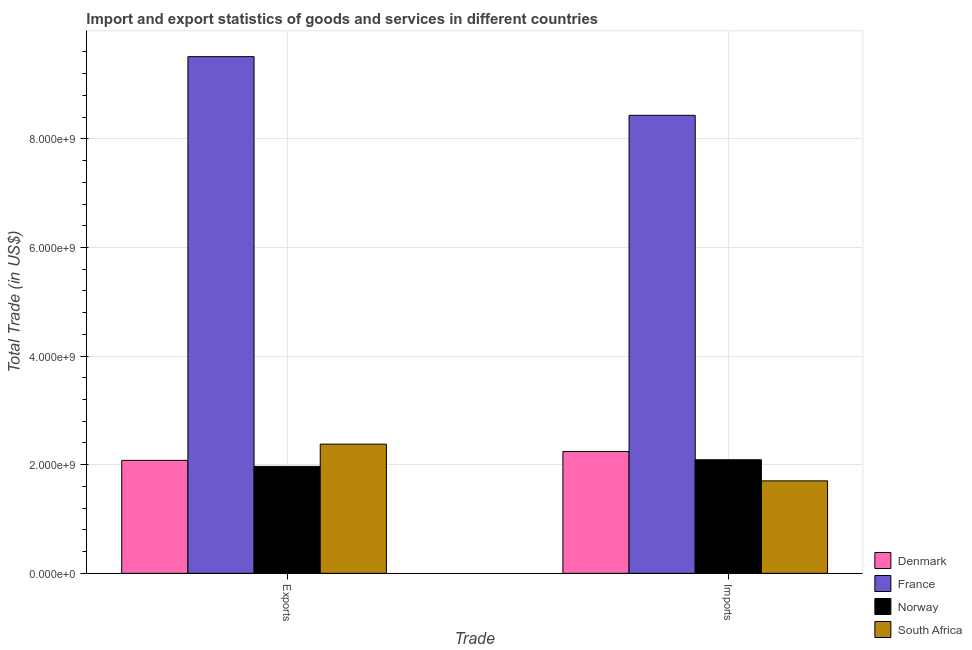How many groups of bars are there?
Your answer should be very brief. 2. Are the number of bars per tick equal to the number of legend labels?
Offer a terse response. Yes. How many bars are there on the 2nd tick from the left?
Your answer should be very brief. 4. What is the label of the 1st group of bars from the left?
Give a very brief answer. Exports. What is the imports of goods and services in Norway?
Offer a terse response. 2.09e+09. Across all countries, what is the maximum export of goods and services?
Your answer should be compact. 9.51e+09. Across all countries, what is the minimum imports of goods and services?
Your answer should be compact. 1.70e+09. In which country was the export of goods and services maximum?
Your response must be concise. France. In which country was the export of goods and services minimum?
Ensure brevity in your answer.  Norway. What is the total export of goods and services in the graph?
Provide a succinct answer. 1.59e+1. What is the difference between the export of goods and services in Norway and that in South Africa?
Your answer should be compact. -4.10e+08. What is the difference between the export of goods and services in Norway and the imports of goods and services in South Africa?
Provide a succinct answer. 2.66e+08. What is the average imports of goods and services per country?
Your response must be concise. 3.62e+09. What is the difference between the export of goods and services and imports of goods and services in South Africa?
Ensure brevity in your answer.  6.77e+08. What is the ratio of the imports of goods and services in Denmark to that in South Africa?
Your answer should be compact. 1.32. Is the imports of goods and services in France less than that in Norway?
Offer a terse response. No. What does the 1st bar from the left in Imports represents?
Ensure brevity in your answer.  Denmark. What does the 2nd bar from the right in Exports represents?
Your answer should be very brief. Norway. How many bars are there?
Provide a short and direct response. 8. Are all the bars in the graph horizontal?
Provide a short and direct response. No. How many countries are there in the graph?
Provide a succinct answer. 4. How are the legend labels stacked?
Offer a terse response. Vertical. What is the title of the graph?
Your answer should be very brief. Import and export statistics of goods and services in different countries. What is the label or title of the X-axis?
Keep it short and to the point. Trade. What is the label or title of the Y-axis?
Your answer should be very brief. Total Trade (in US$). What is the Total Trade (in US$) in Denmark in Exports?
Give a very brief answer. 2.08e+09. What is the Total Trade (in US$) of France in Exports?
Your answer should be compact. 9.51e+09. What is the Total Trade (in US$) in Norway in Exports?
Your response must be concise. 1.97e+09. What is the Total Trade (in US$) in South Africa in Exports?
Your response must be concise. 2.38e+09. What is the Total Trade (in US$) of Denmark in Imports?
Keep it short and to the point. 2.24e+09. What is the Total Trade (in US$) of France in Imports?
Keep it short and to the point. 8.43e+09. What is the Total Trade (in US$) of Norway in Imports?
Provide a short and direct response. 2.09e+09. What is the Total Trade (in US$) of South Africa in Imports?
Your answer should be very brief. 1.70e+09. Across all Trade, what is the maximum Total Trade (in US$) in Denmark?
Keep it short and to the point. 2.24e+09. Across all Trade, what is the maximum Total Trade (in US$) in France?
Provide a succinct answer. 9.51e+09. Across all Trade, what is the maximum Total Trade (in US$) in Norway?
Offer a terse response. 2.09e+09. Across all Trade, what is the maximum Total Trade (in US$) of South Africa?
Offer a terse response. 2.38e+09. Across all Trade, what is the minimum Total Trade (in US$) of Denmark?
Your answer should be very brief. 2.08e+09. Across all Trade, what is the minimum Total Trade (in US$) in France?
Your answer should be very brief. 8.43e+09. Across all Trade, what is the minimum Total Trade (in US$) of Norway?
Give a very brief answer. 1.97e+09. Across all Trade, what is the minimum Total Trade (in US$) in South Africa?
Provide a short and direct response. 1.70e+09. What is the total Total Trade (in US$) of Denmark in the graph?
Your answer should be very brief. 4.32e+09. What is the total Total Trade (in US$) of France in the graph?
Provide a short and direct response. 1.79e+1. What is the total Total Trade (in US$) of Norway in the graph?
Give a very brief answer. 4.06e+09. What is the total Total Trade (in US$) in South Africa in the graph?
Your response must be concise. 4.08e+09. What is the difference between the Total Trade (in US$) of Denmark in Exports and that in Imports?
Offer a terse response. -1.63e+08. What is the difference between the Total Trade (in US$) in France in Exports and that in Imports?
Provide a succinct answer. 1.08e+09. What is the difference between the Total Trade (in US$) of Norway in Exports and that in Imports?
Offer a very short reply. -1.23e+08. What is the difference between the Total Trade (in US$) in South Africa in Exports and that in Imports?
Offer a very short reply. 6.77e+08. What is the difference between the Total Trade (in US$) of Denmark in Exports and the Total Trade (in US$) of France in Imports?
Provide a succinct answer. -6.35e+09. What is the difference between the Total Trade (in US$) of Denmark in Exports and the Total Trade (in US$) of Norway in Imports?
Your answer should be very brief. -1.15e+07. What is the difference between the Total Trade (in US$) of Denmark in Exports and the Total Trade (in US$) of South Africa in Imports?
Give a very brief answer. 3.78e+08. What is the difference between the Total Trade (in US$) of France in Exports and the Total Trade (in US$) of Norway in Imports?
Ensure brevity in your answer.  7.42e+09. What is the difference between the Total Trade (in US$) in France in Exports and the Total Trade (in US$) in South Africa in Imports?
Ensure brevity in your answer.  7.81e+09. What is the difference between the Total Trade (in US$) of Norway in Exports and the Total Trade (in US$) of South Africa in Imports?
Offer a terse response. 2.66e+08. What is the average Total Trade (in US$) in Denmark per Trade?
Provide a short and direct response. 2.16e+09. What is the average Total Trade (in US$) of France per Trade?
Provide a succinct answer. 8.97e+09. What is the average Total Trade (in US$) in Norway per Trade?
Your answer should be very brief. 2.03e+09. What is the average Total Trade (in US$) in South Africa per Trade?
Your answer should be very brief. 2.04e+09. What is the difference between the Total Trade (in US$) of Denmark and Total Trade (in US$) of France in Exports?
Your answer should be very brief. -7.43e+09. What is the difference between the Total Trade (in US$) in Denmark and Total Trade (in US$) in Norway in Exports?
Provide a short and direct response. 1.11e+08. What is the difference between the Total Trade (in US$) of Denmark and Total Trade (in US$) of South Africa in Exports?
Your answer should be compact. -2.99e+08. What is the difference between the Total Trade (in US$) in France and Total Trade (in US$) in Norway in Exports?
Your response must be concise. 7.54e+09. What is the difference between the Total Trade (in US$) of France and Total Trade (in US$) of South Africa in Exports?
Your answer should be very brief. 7.13e+09. What is the difference between the Total Trade (in US$) in Norway and Total Trade (in US$) in South Africa in Exports?
Give a very brief answer. -4.10e+08. What is the difference between the Total Trade (in US$) in Denmark and Total Trade (in US$) in France in Imports?
Your response must be concise. -6.19e+09. What is the difference between the Total Trade (in US$) of Denmark and Total Trade (in US$) of Norway in Imports?
Ensure brevity in your answer.  1.51e+08. What is the difference between the Total Trade (in US$) in Denmark and Total Trade (in US$) in South Africa in Imports?
Your answer should be very brief. 5.40e+08. What is the difference between the Total Trade (in US$) of France and Total Trade (in US$) of Norway in Imports?
Provide a succinct answer. 6.34e+09. What is the difference between the Total Trade (in US$) in France and Total Trade (in US$) in South Africa in Imports?
Give a very brief answer. 6.73e+09. What is the difference between the Total Trade (in US$) of Norway and Total Trade (in US$) of South Africa in Imports?
Offer a very short reply. 3.89e+08. What is the ratio of the Total Trade (in US$) of Denmark in Exports to that in Imports?
Give a very brief answer. 0.93. What is the ratio of the Total Trade (in US$) in France in Exports to that in Imports?
Offer a very short reply. 1.13. What is the ratio of the Total Trade (in US$) in Norway in Exports to that in Imports?
Your answer should be very brief. 0.94. What is the ratio of the Total Trade (in US$) in South Africa in Exports to that in Imports?
Provide a succinct answer. 1.4. What is the difference between the highest and the second highest Total Trade (in US$) in Denmark?
Offer a very short reply. 1.63e+08. What is the difference between the highest and the second highest Total Trade (in US$) of France?
Provide a short and direct response. 1.08e+09. What is the difference between the highest and the second highest Total Trade (in US$) of Norway?
Offer a very short reply. 1.23e+08. What is the difference between the highest and the second highest Total Trade (in US$) in South Africa?
Provide a succinct answer. 6.77e+08. What is the difference between the highest and the lowest Total Trade (in US$) of Denmark?
Ensure brevity in your answer.  1.63e+08. What is the difference between the highest and the lowest Total Trade (in US$) of France?
Provide a succinct answer. 1.08e+09. What is the difference between the highest and the lowest Total Trade (in US$) of Norway?
Ensure brevity in your answer.  1.23e+08. What is the difference between the highest and the lowest Total Trade (in US$) of South Africa?
Give a very brief answer. 6.77e+08. 